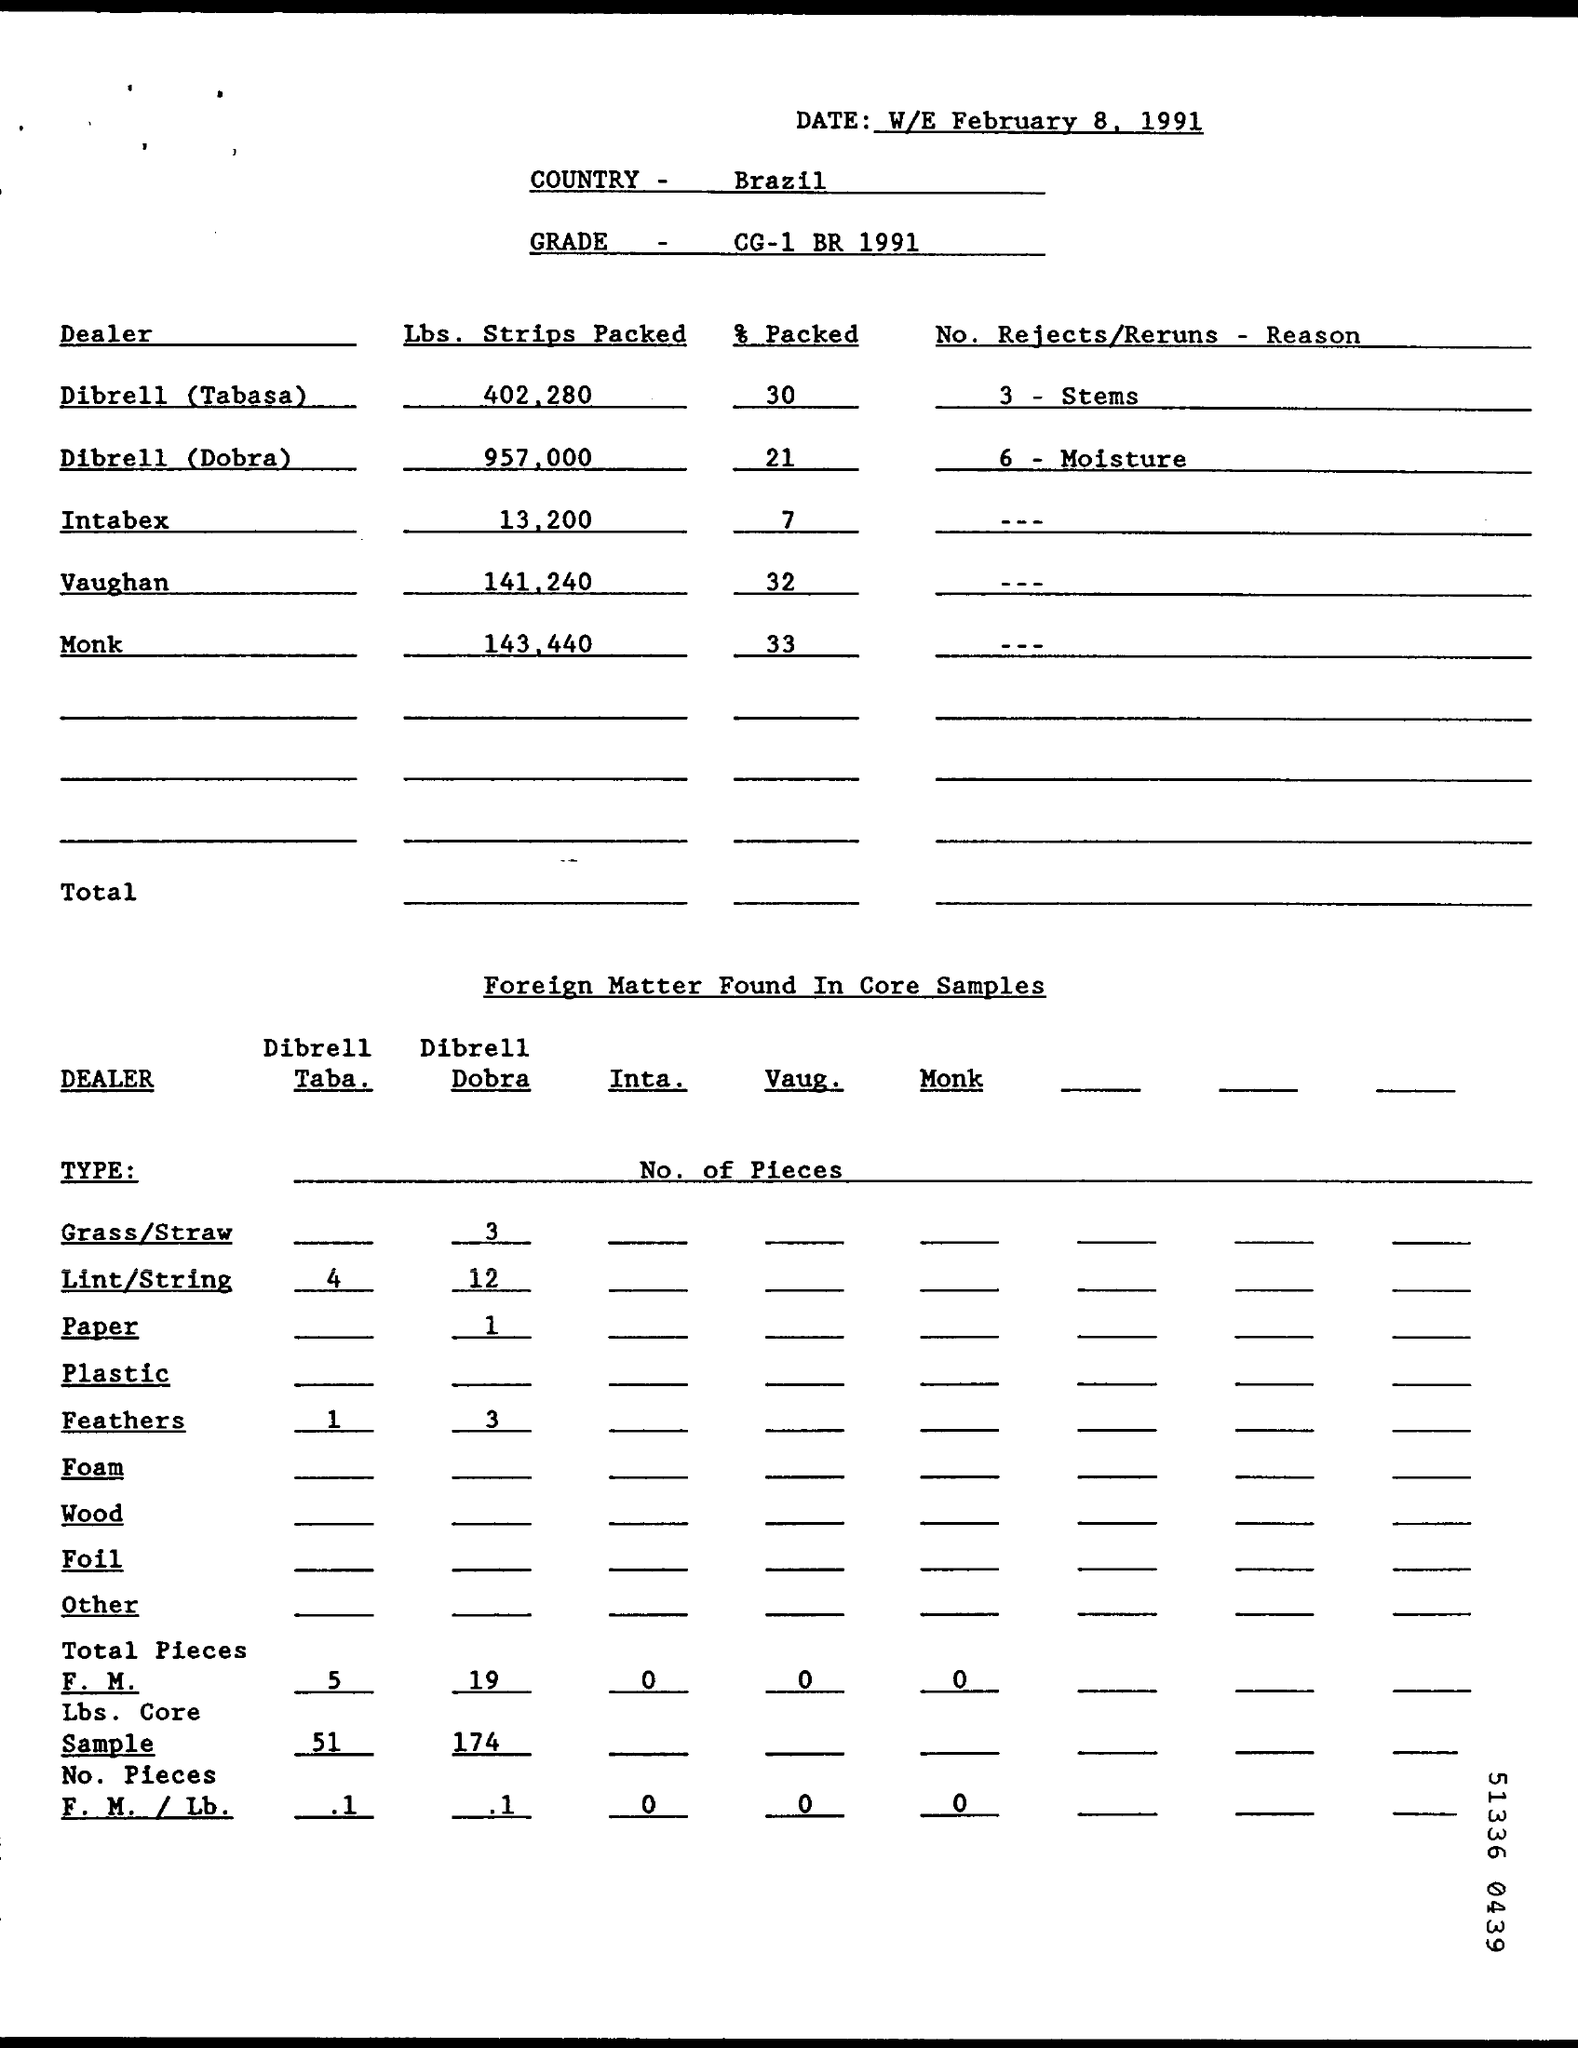Highlight a few significant elements in this photo. Brazil is mentioned. The packaging of the product was completed by Dibrell (Dobra) to the extent of 21%. The grade specified is CG-1 BR 1991. The document is dated February 8, 1991. 